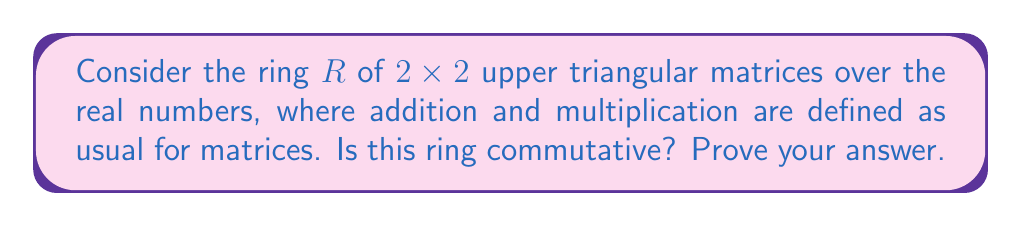What is the answer to this math problem? To determine if the ring $R$ is commutative, we need to check if $ab = ba$ for all elements $a, b \in R$.

Let's consider two general elements of $R$:

$$a = \begin{pmatrix} x_1 & y_1 \\ 0 & z_1 \end{pmatrix} \text{ and } b = \begin{pmatrix} x_2 & y_2 \\ 0 & z_2 \end{pmatrix}$$

where $x_1, y_1, z_1, x_2, y_2, z_2 \in \mathbb{R}$.

Now, let's multiply $ab$ and $ba$:

$$ab = \begin{pmatrix} x_1 & y_1 \\ 0 & z_1 \end{pmatrix} \begin{pmatrix} x_2 & y_2 \\ 0 & z_2 \end{pmatrix} = \begin{pmatrix} x_1x_2 & x_1y_2 + y_1z_2 \\ 0 & z_1z_2 \end{pmatrix}$$

$$ba = \begin{pmatrix} x_2 & y_2 \\ 0 & z_2 \end{pmatrix} \begin{pmatrix} x_1 & y_1 \\ 0 & z_1 \end{pmatrix} = \begin{pmatrix} x_2x_1 & x_2y_1 + y_2z_1 \\ 0 & z_2z_1 \end{pmatrix}$$

For $R$ to be commutative, we need $ab = ba$ for all choices of $x_1, y_1, z_1, x_2, y_2, z_2$. Let's compare the corresponding elements:

1. Top-left: $x_1x_2 = x_2x_1$ (always true for real numbers)
2. Bottom-left: $0 = 0$ (always true)
3. Bottom-right: $z_1z_2 = z_2z_1$ (always true for real numbers)
4. Top-right: $x_1y_2 + y_1z_2 = x_2y_1 + y_2z_1$

The first three conditions are always satisfied, but the fourth condition is not generally true. For example, if we choose:

$x_1 = 1, y_1 = 0, z_1 = 1, x_2 = 1, y_2 = 1, z_2 = 0$

Then $x_1y_2 + y_1z_2 = 1 \neq 0 = x_2y_1 + y_2z_1$

Therefore, we can conclude that $R$ is not commutative.
Answer: The ring $R$ of $2\times 2$ upper triangular matrices over the real numbers is not commutative. 